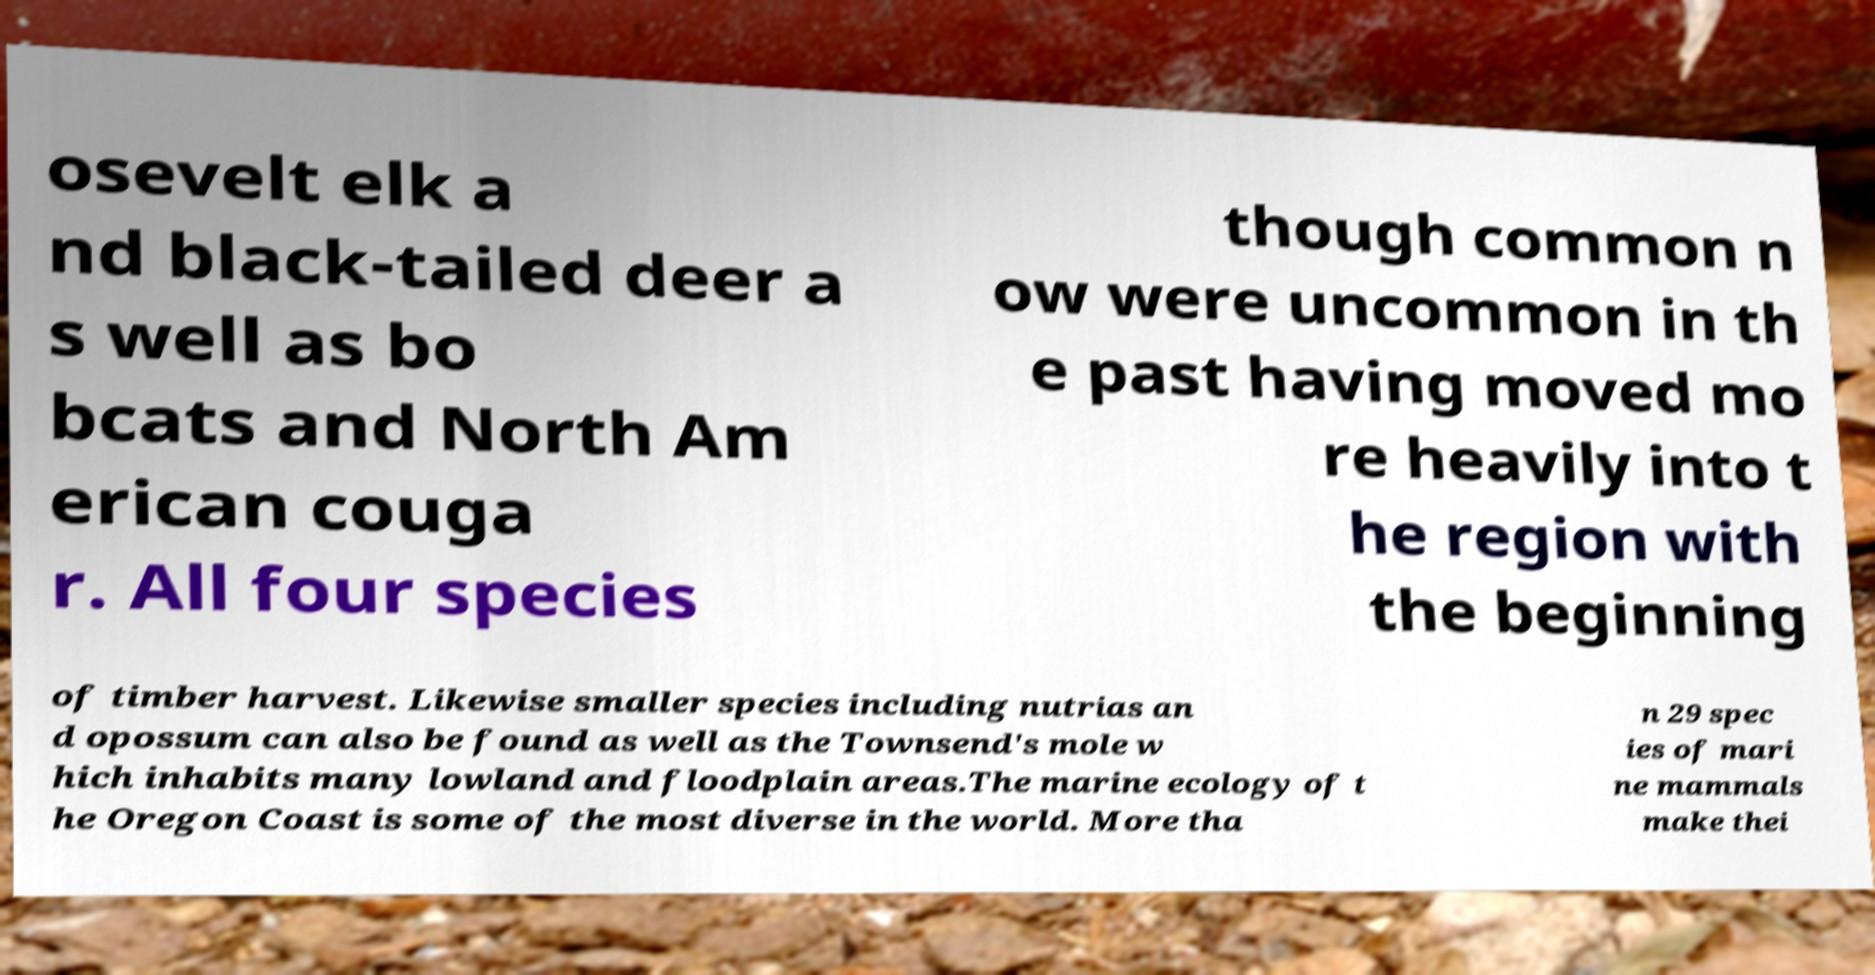I need the written content from this picture converted into text. Can you do that? osevelt elk a nd black-tailed deer a s well as bo bcats and North Am erican couga r. All four species though common n ow were uncommon in th e past having moved mo re heavily into t he region with the beginning of timber harvest. Likewise smaller species including nutrias an d opossum can also be found as well as the Townsend's mole w hich inhabits many lowland and floodplain areas.The marine ecology of t he Oregon Coast is some of the most diverse in the world. More tha n 29 spec ies of mari ne mammals make thei 